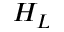<formula> <loc_0><loc_0><loc_500><loc_500>H _ { L }</formula> 